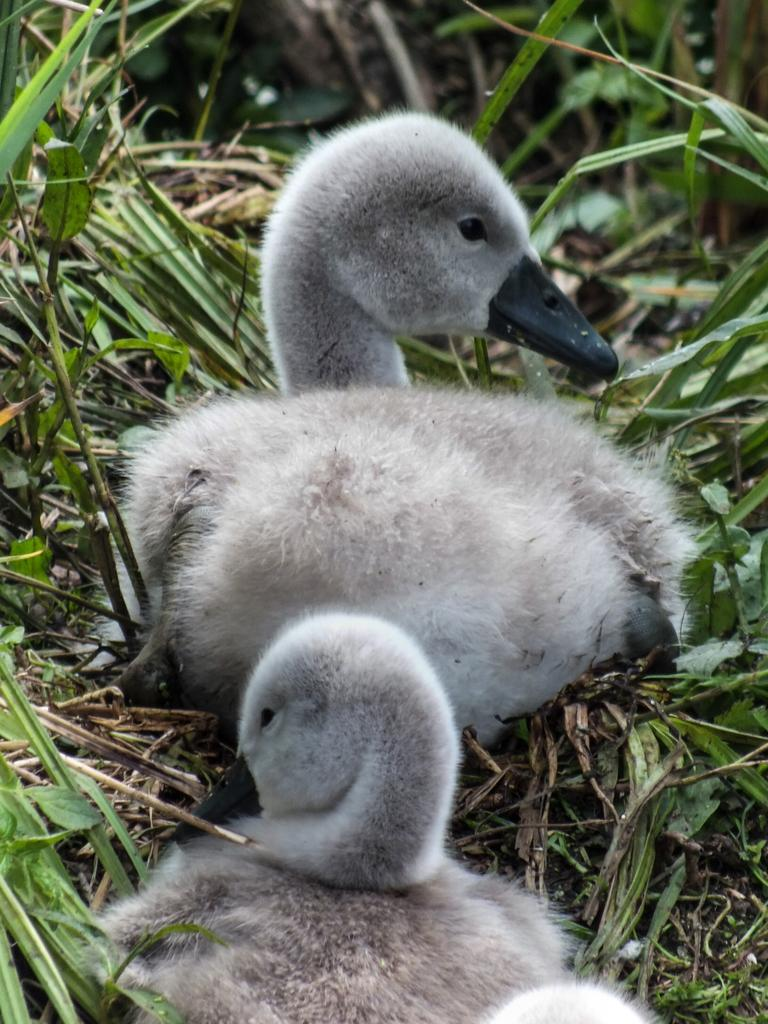What type of animals can be seen in the image? Birds can be seen in the image. What type of vegetation is present in the image? There is grass in the image. What type of wool can be seen on the fairies in the image? There are no fairies or wool present in the image; it features birds and grass. 